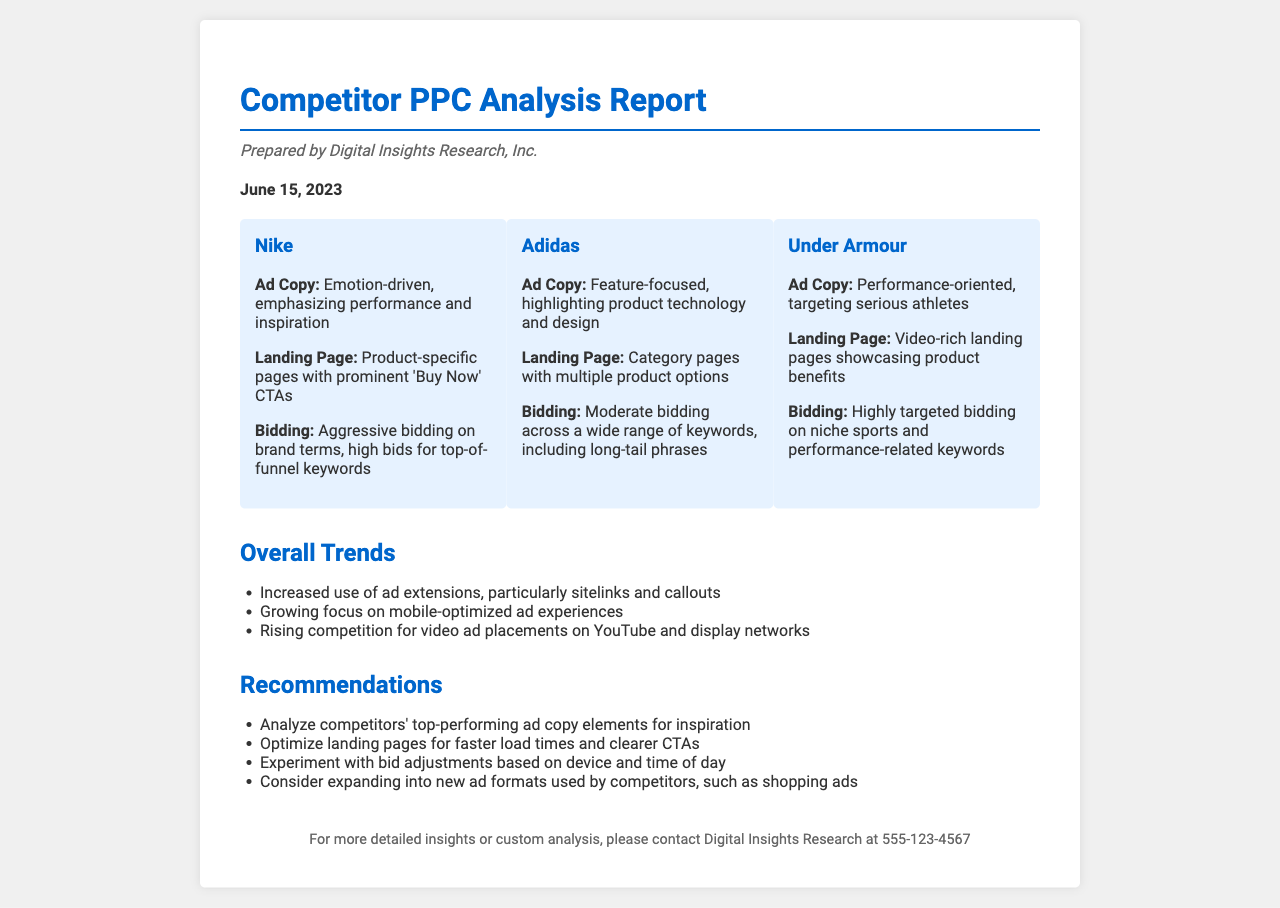What is the date of the report? The date of the report is presented clearly in the document as the date it was prepared, which is June 15, 2023.
Answer: June 15, 2023 Who prepared the report? The report mentions the firm that prepared it, which is Digital Insights Research, Inc.
Answer: Digital Insights Research, Inc What is Nike’s ad copy focus? The document states that Nike's ad copy is emotion-driven, emphasizing performance and inspiration.
Answer: Emotion-driven, emphasizing performance and inspiration How does Under Armour structure its landing page? The document describes Under Armour's landing page as video-rich, showcasing product benefits.
Answer: Video-rich landing pages showcasing product benefits What type of bidding strategy does Adidas use? The report highlights that Adidas employs a moderate bidding strategy across a wide range of keywords.
Answer: Moderate bidding across a wide range of keywords What overall trend is mentioned regarding ad extensions? The document notes an increased use of ad extensions, particularly sitelinks and callouts, as a trend.
Answer: Increased use of ad extensions, particularly sitelinks and callouts What device-based recommendation is provided in the document? The recommendations state to experiment with bid adjustments based on device as a strategic move.
Answer: Experiment with bid adjustments based on device How many competitors are analyzed in the report? The document lists three competitors that are analyzed for their PPC strategies.
Answer: Three competitors 